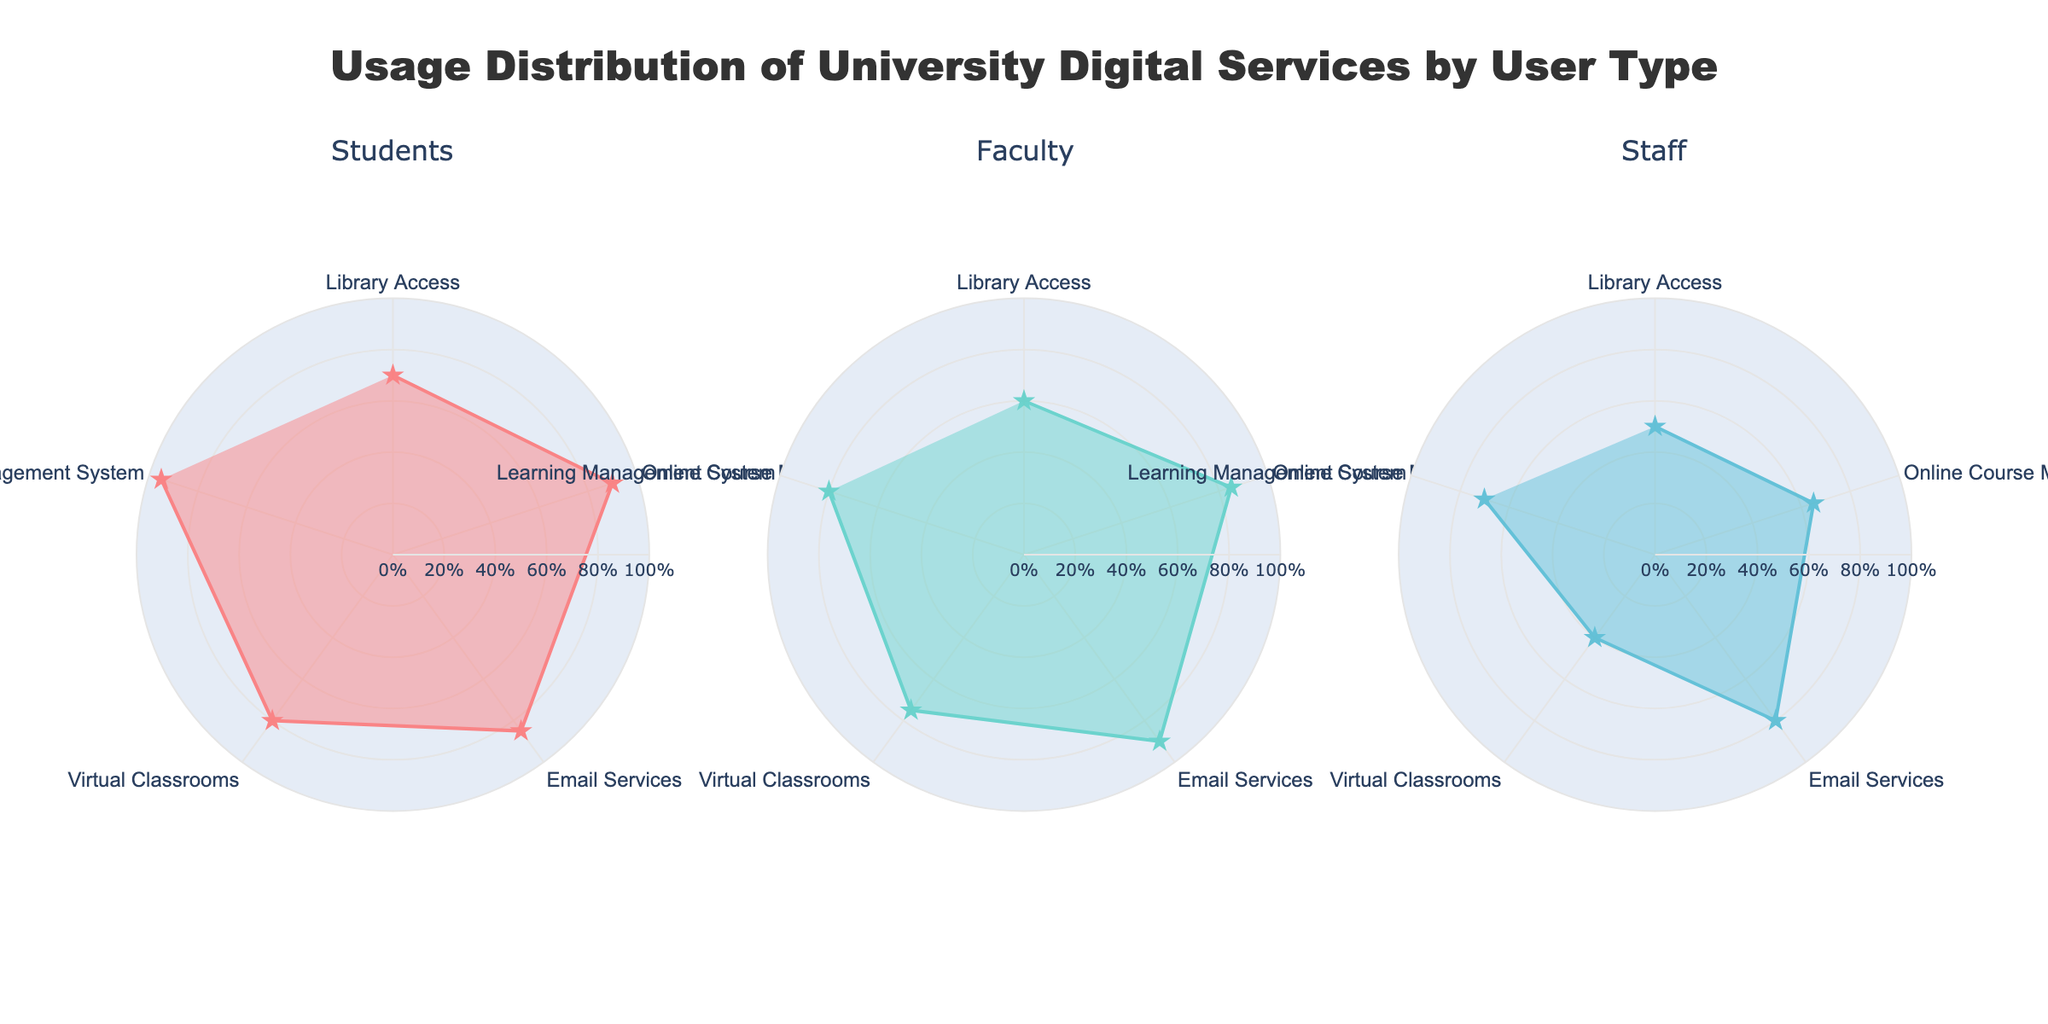What is the title of the plot? The title of the plot is located at the top center of the figure. You can read it directly as "Usage Distribution of University Digital Services by User Type".
Answer: Usage Distribution of University Digital Services by User Type Which user type has the highest usage percentage for Email Services? To determine the user type with the highest usage percentage for Email Services, look at the radial (outermost) position for "Email Services" in each of the three Polar Charts. The percentage for Faculty is the highest at 90%.
Answer: Faculty What is the range of the radial axis in the plots? The radial axis range can be determined by observing the values on the radial grid lines in any of the subplots. The range of the radial axis is from 0% to 100%.
Answer: 0% to 100% Which digital service shows the greatest difference in usage percentage between Students and Staff? Examine the usage percentages of each service for both Students and Staff. Compute the differences: Library Access (70% - 50% = 20%), Online Course Materials (90% - 65% = 25%), Email Services (85% - 80% = 5%), Virtual Classrooms (80% - 40% = 40%), Learning Management System (95% - 70% = 25%). The greatest difference is for Virtual Classrooms at 40%.
Answer: Virtual Classrooms For Faculty, which digital service has the lowest usage percentage? To find the lowest usage percentage for Faculty, look at the minimum radial (innermost) position of the data points in the Faculty Polar Chart. The lowest percentage is for Virtual Classrooms at 75%.
Answer: Virtual Classrooms What is the average usage percentage of Learning Management System across all user types? Calculate the average by summing the usage percentages of the Learning Management System across all user types and then dividing by the number of user types: (95% for Students + 80% for Faculty + 70% for Staff) / 3 = 245% / 3 = 81.67%.
Answer: 81.67% Which digital service is used the least by Staff? In the Staff subplot, the service with the smallest radial value (closest to the center) is Virtual Classrooms at 40%.
Answer: Virtual Classrooms Which user type shows the most balanced usage across all digital services? Balance can be assessed by the consistency of the radial distances. Students and Faculty show relatively balanced usage, but Faculty has a more uniform radial distribution across services (ranging from 60% to 90%) compared to Students (ranging from 70% to 95%). Thus, Faculty is the most balanced.
Answer: Faculty How much higher is the usage percentage of Online Course Materials compared to Library Access for Staff? Subtract the usage percentage of Library Access from that of Online Course Materials for Staff: 65% - 50% = 15%.
Answer: 15% What is the sum of usage percentages for Virtual Classrooms across all user types? Add the usage percentages of Virtual Classrooms for Students, Faculty, and Staff: 80% (Students) + 75% (Faculty) + 40% (Staff) = 195%.
Answer: 195% 